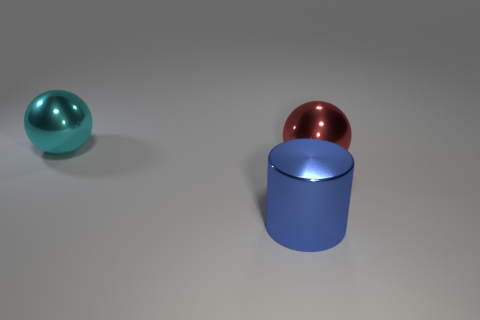Add 2 blue shiny objects. How many objects exist? 5 Subtract all cylinders. How many objects are left? 2 Add 1 large blue metallic objects. How many large blue metallic objects are left? 2 Add 1 big cyan things. How many big cyan things exist? 2 Subtract 1 blue cylinders. How many objects are left? 2 Subtract all red things. Subtract all large gray rubber cubes. How many objects are left? 2 